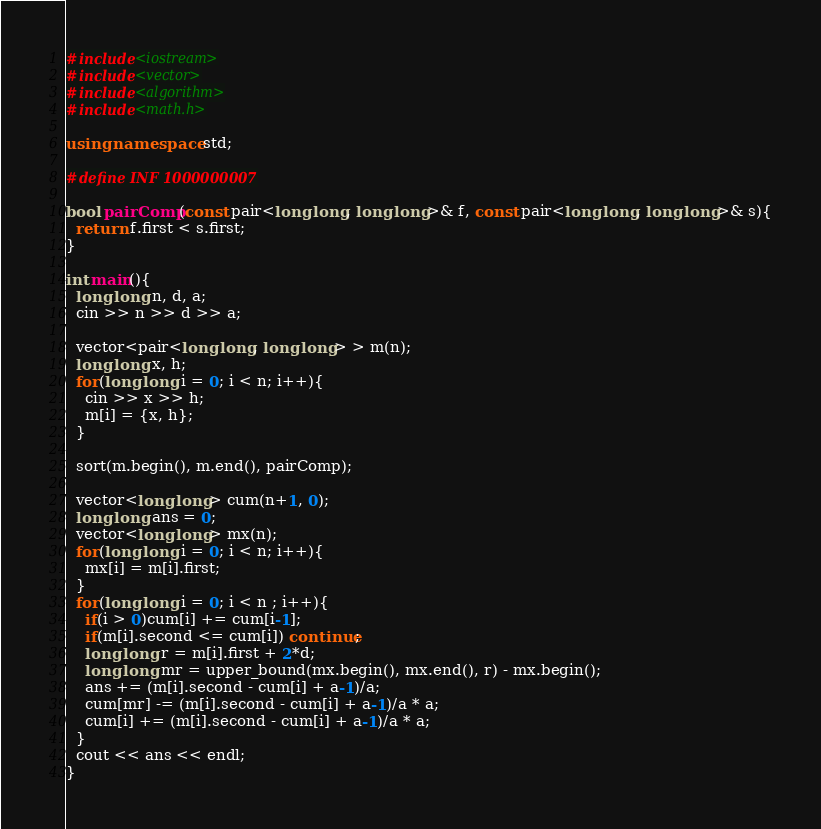Convert code to text. <code><loc_0><loc_0><loc_500><loc_500><_C++_>#include<iostream>
#include<vector>
#include<algorithm>
#include<math.h>

using namespace std;

#define INF 1000000007

bool pairComp(const pair<long long, long long>& f, const pair<long long, long long>& s){
  return f.first < s.first;
}

int main(){
  long long n, d, a;
  cin >> n >> d >> a;

  vector<pair<long long, long long> > m(n);
  long long x, h;
  for(long long i = 0; i < n; i++){
    cin >> x >> h;
    m[i] = {x, h};
  }

  sort(m.begin(), m.end(), pairComp);

  vector<long long> cum(n+1, 0);
  long long ans = 0;
  vector<long long> mx(n);
  for(long long i = 0; i < n; i++){
    mx[i] = m[i].first;
  }
  for(long long i = 0; i < n ; i++){
    if(i > 0)cum[i] += cum[i-1];
    if(m[i].second <= cum[i]) continue;
    long long r = m[i].first + 2*d;
    long long mr = upper_bound(mx.begin(), mx.end(), r) - mx.begin();
    ans += (m[i].second - cum[i] + a-1)/a;
    cum[mr] -= (m[i].second - cum[i] + a-1)/a * a;
    cum[i] += (m[i].second - cum[i] + a-1)/a * a;
  }
  cout << ans << endl;
}
</code> 